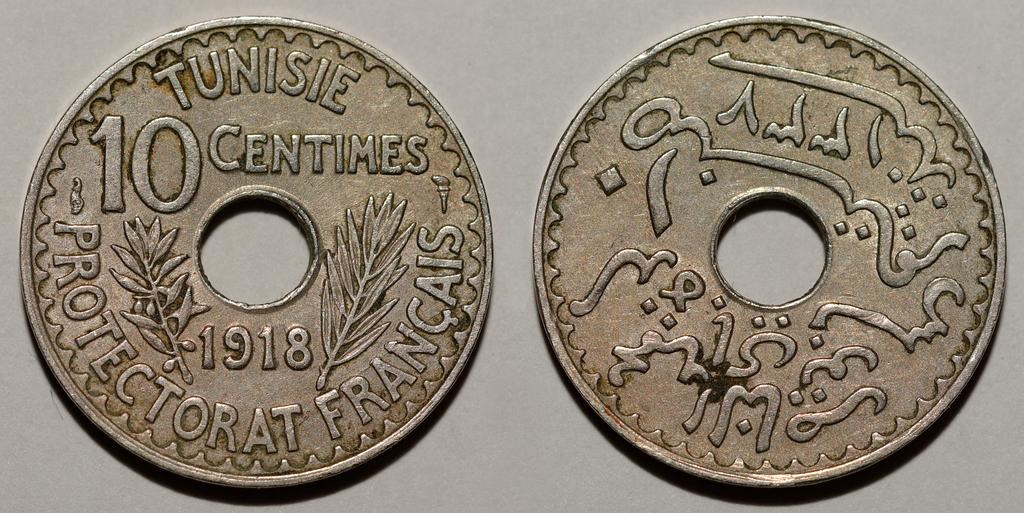<image>
Write a terse but informative summary of the picture. A coin has a whole in the center and the year 1918 on it. 